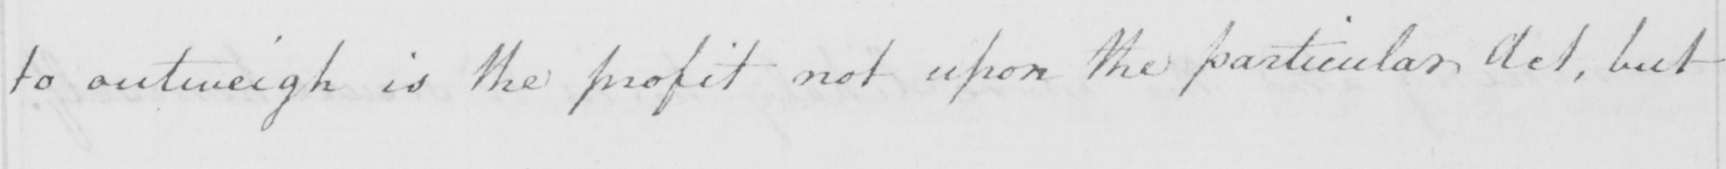What does this handwritten line say? to outweigh is the profit not upon the particular Act , but 